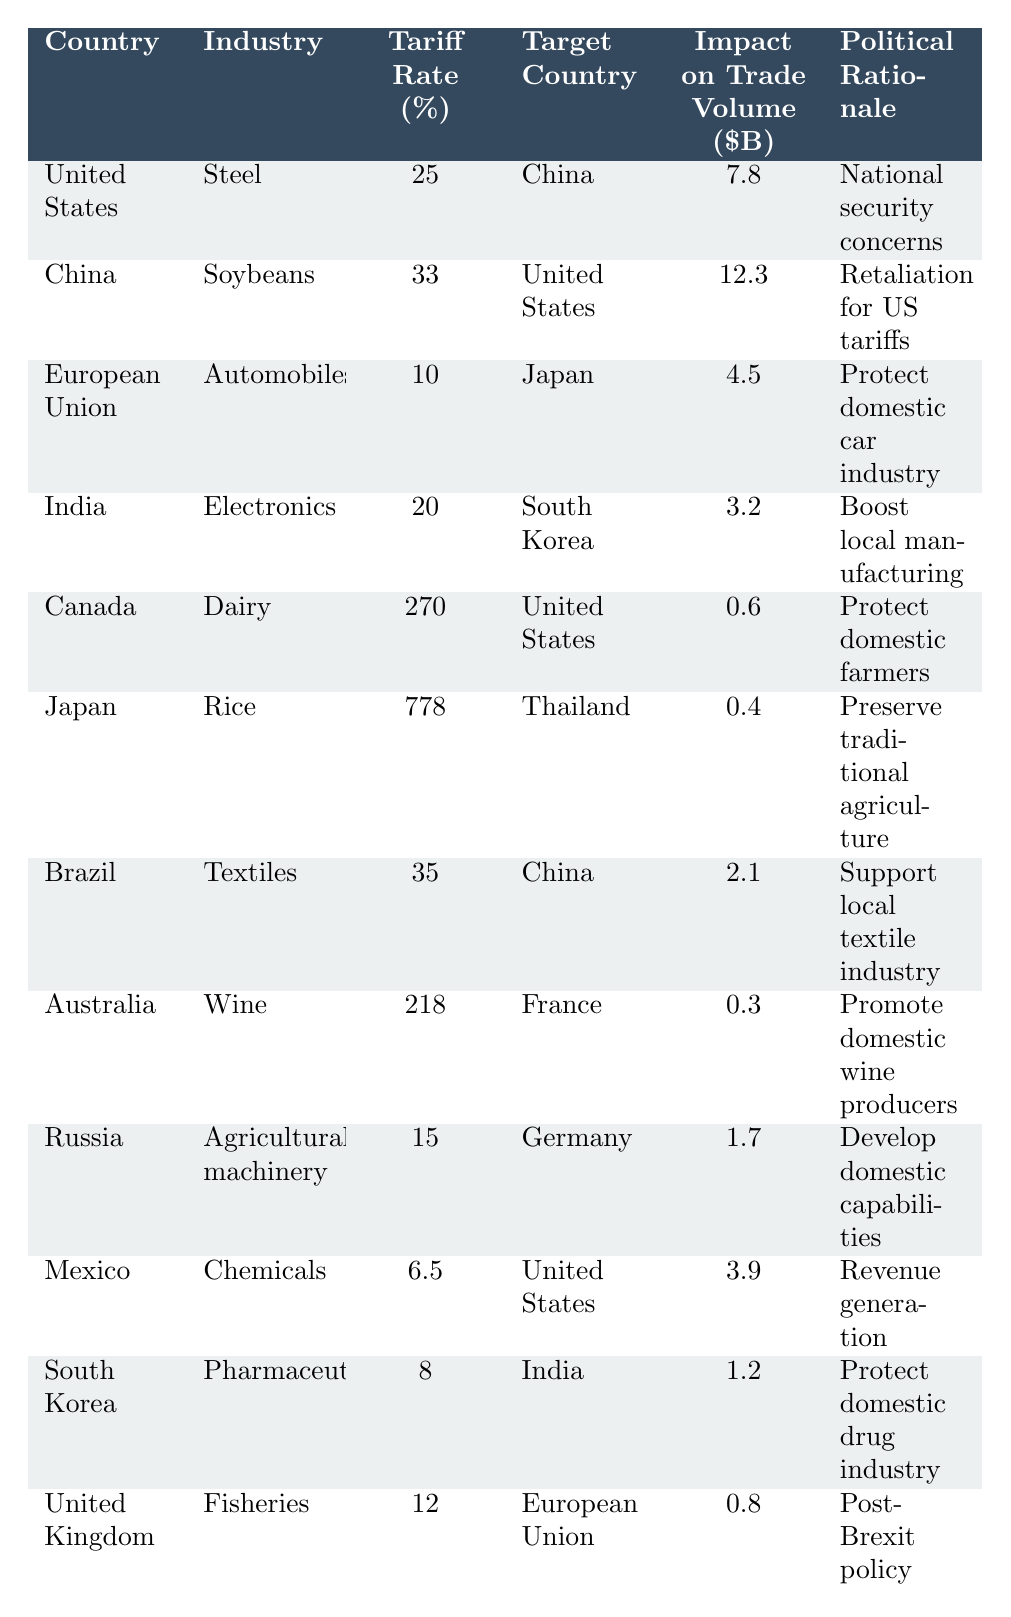What is the tariff rate imposed by Canada on Dairy? In the table, look for Canada under the "Country" column and find the corresponding "Tariff Rate (%)" in the same row, which is 270%.
Answer: 270% Which industry has the highest tariff imposed, and what is the tariff rate? The highest tariff in the table is for Rice, imposed by Japan at a rate of 778%.
Answer: Rice, 778% What is the impact on trade volume of the United States imposing tariffs on Steel? In the table, find the row for the United States under the "Country" column. The corresponding "Impact on Trade Volume ($B)" is 7.8 billion dollars.
Answer: 7.8 billion Is the political rationale for China's tariffs on Soybeans related to retaliation? Yes, according to the "Political Rationale" column, China's tariffs are described as "Retaliation for US tariffs."
Answer: Yes Calculate the total tariff rate of the Electronics industry imposed by India and Pharmaceuticals industry imposed by South Korea. The tariff rate for Electronics (India) is 20%, and for Pharmaceuticals (South Korea) it is 8%. Adding these together gives 20 + 8 = 28%.
Answer: 28% Which country targets the United States with the highest tariff and what is the rate? Check the rows targeting the United States. Canada imposes the highest tariff at 270% on Dairy.
Answer: Canada, 270% What is the average tariff rate of the industries listed in the table? To find the average, sum all the tariff rates: (25 + 33 + 10 + 20 + 270 + 778 + 35 + 218 + 15 + 6.5 + 8 + 12) = 1410.5. There are 12 entries, so the average is 1410.5 / 12 = 117.54%.
Answer: 117.54% Did any country impose tariffs higher than 100%? Yes, there are two instances: Canada on Dairy (270%) and Japan on Rice (778%).
Answer: Yes Which industry has the lowest tariff imposed and what is the rate? By reviewing the "Tariff Rate (%)" column, the lowest tariff is for Chemicals, imposed by Mexico at 6.5%.
Answer: Chemicals, 6.5% Identify two countries that impose tariffs as a measure to protect their domestic industry. In the table, India (Electronics, 20%) and South Korea (Pharmaceuticals, 8%) both mention protection of their domestic industries in the "Political Rationale" column.
Answer: India and South Korea 